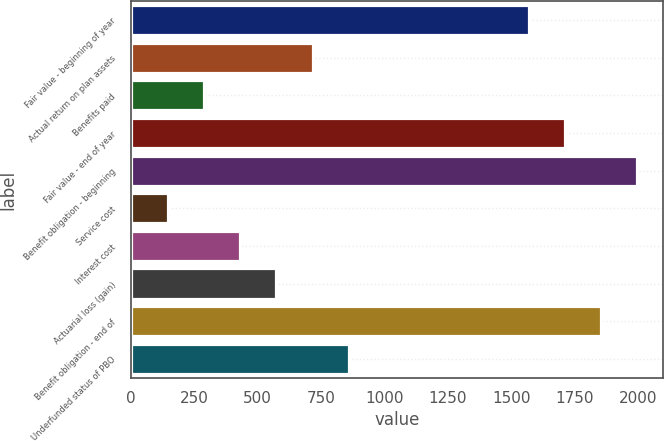<chart> <loc_0><loc_0><loc_500><loc_500><bar_chart><fcel>Fair value - beginning of year<fcel>Actual return on plan assets<fcel>Benefits paid<fcel>Fair value - end of year<fcel>Benefit obligation - beginning<fcel>Service cost<fcel>Interest cost<fcel>Actuarial loss (gain)<fcel>Benefit obligation - end of<fcel>Underfunded status of PBO<nl><fcel>1571.5<fcel>716.5<fcel>289<fcel>1714<fcel>1999<fcel>146.5<fcel>431.5<fcel>574<fcel>1856.5<fcel>859<nl></chart> 